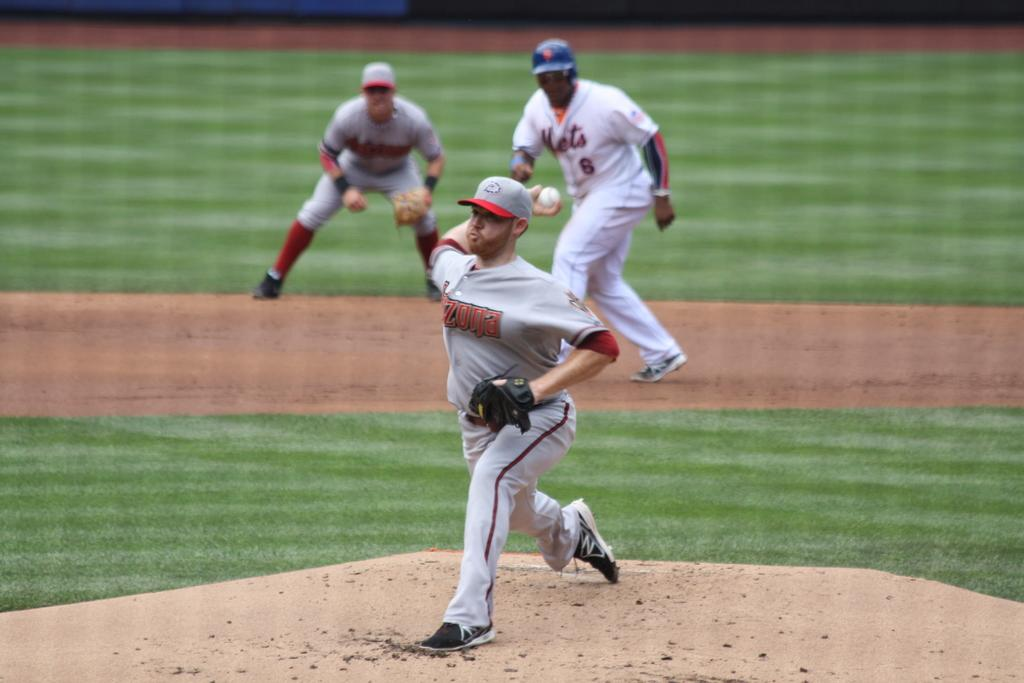<image>
Render a clear and concise summary of the photo. A trio of baseball players are playing on the field with one of them having Mets 6 on his jersey. 